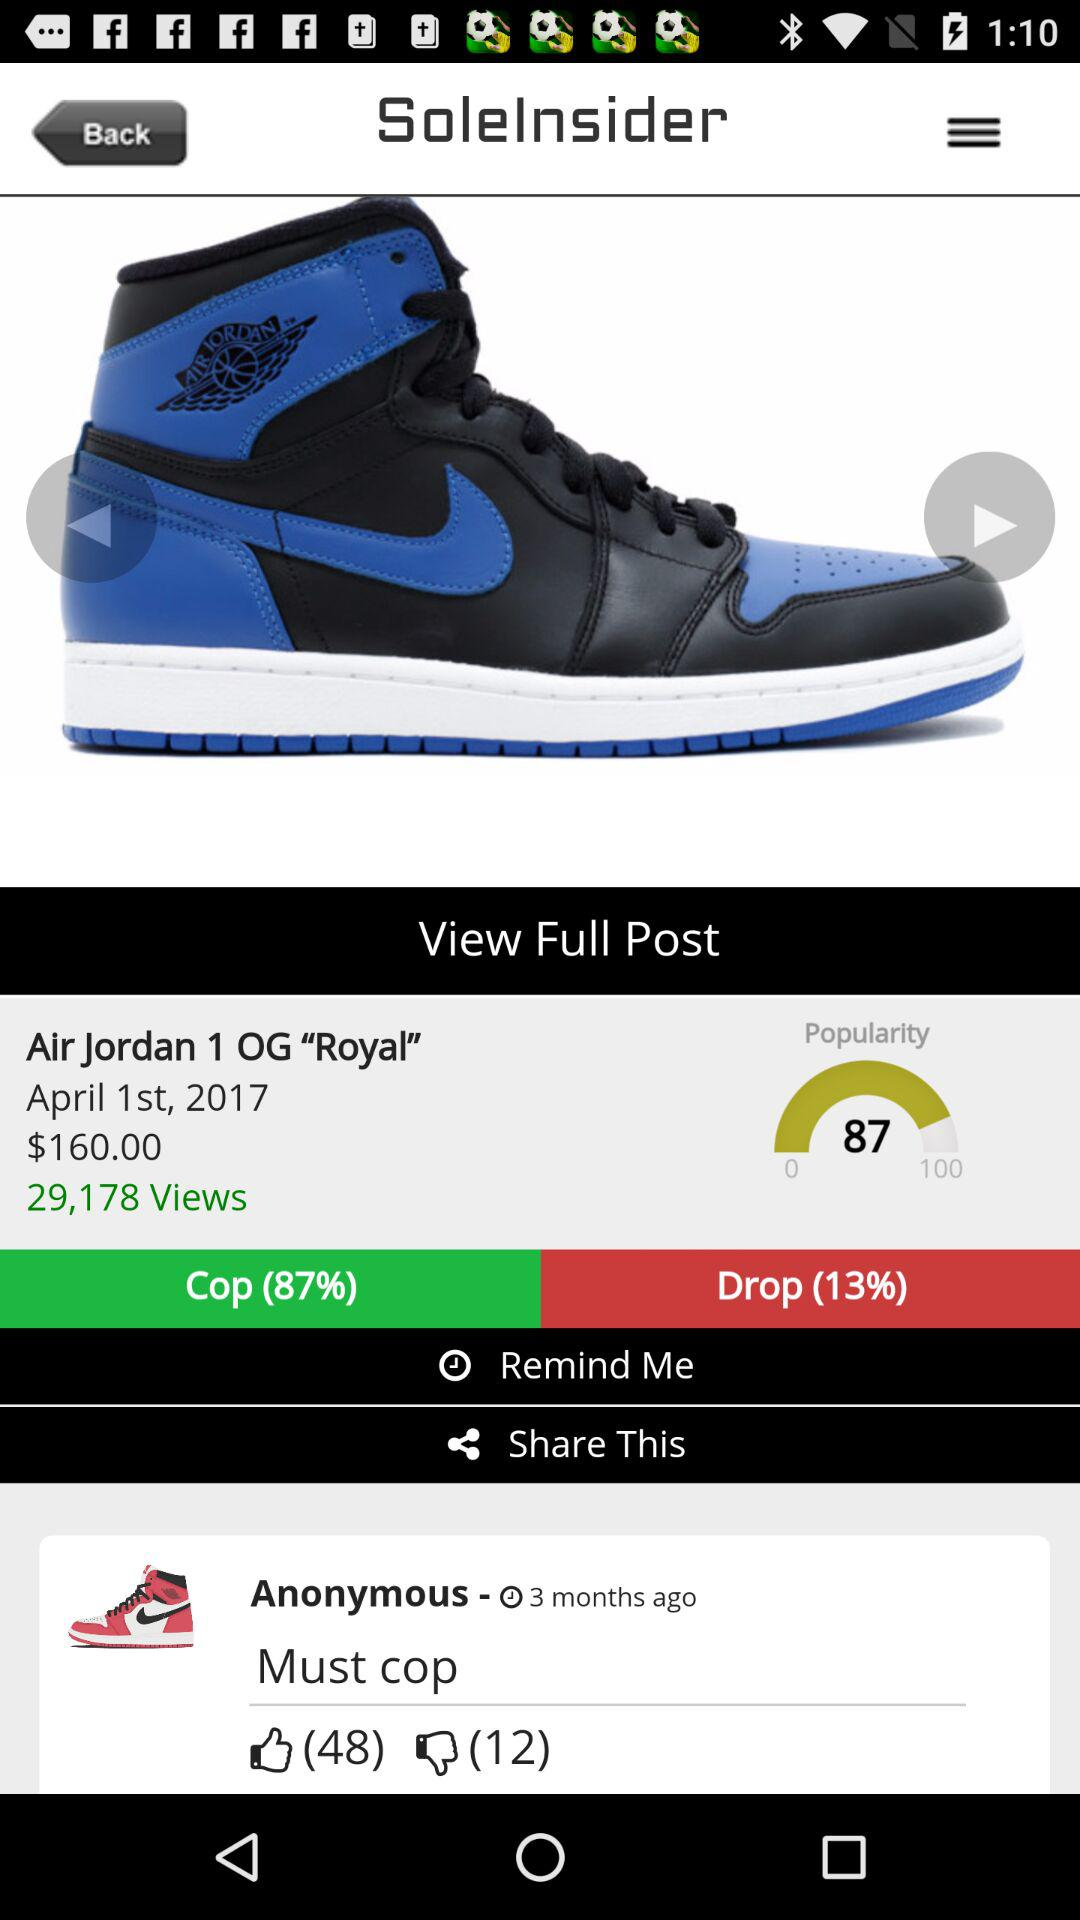How many people disliked the review "Must cop"? There are 12 people who disliked the "Must cop" review. 